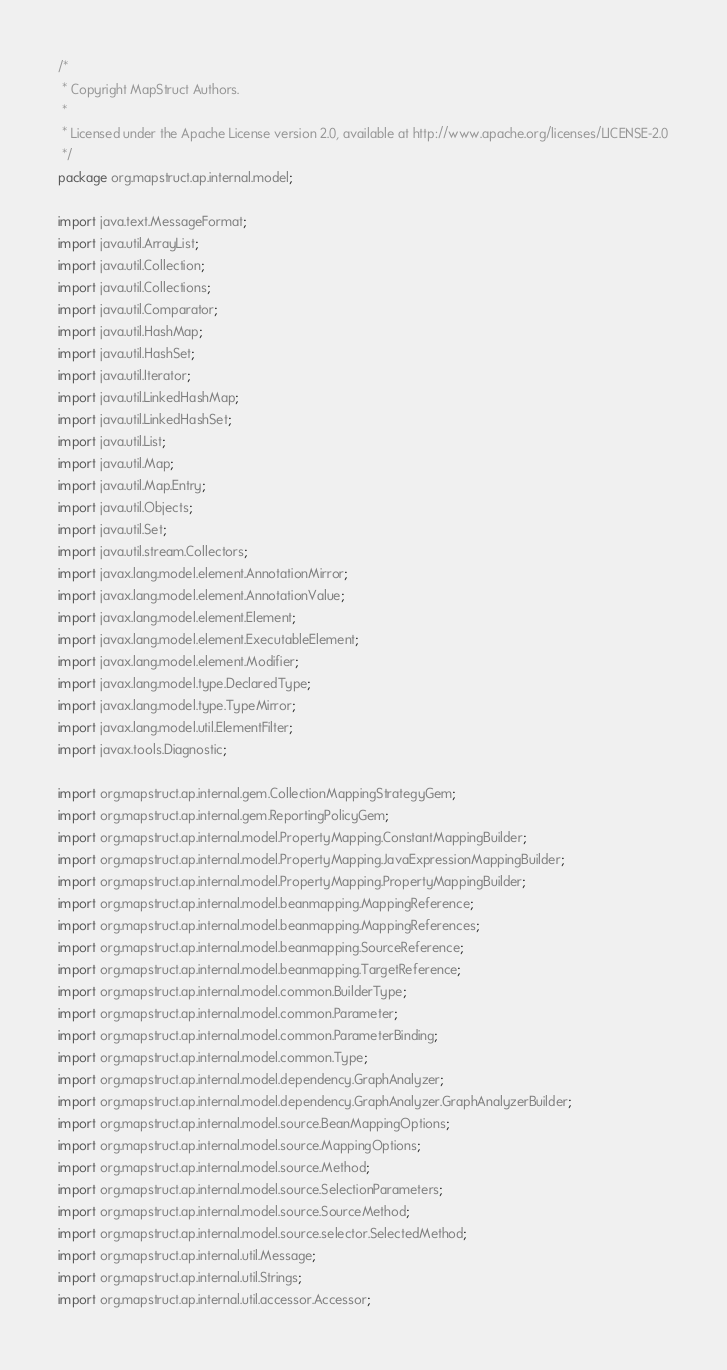<code> <loc_0><loc_0><loc_500><loc_500><_Java_>/*
 * Copyright MapStruct Authors.
 *
 * Licensed under the Apache License version 2.0, available at http://www.apache.org/licenses/LICENSE-2.0
 */
package org.mapstruct.ap.internal.model;

import java.text.MessageFormat;
import java.util.ArrayList;
import java.util.Collection;
import java.util.Collections;
import java.util.Comparator;
import java.util.HashMap;
import java.util.HashSet;
import java.util.Iterator;
import java.util.LinkedHashMap;
import java.util.LinkedHashSet;
import java.util.List;
import java.util.Map;
import java.util.Map.Entry;
import java.util.Objects;
import java.util.Set;
import java.util.stream.Collectors;
import javax.lang.model.element.AnnotationMirror;
import javax.lang.model.element.AnnotationValue;
import javax.lang.model.element.Element;
import javax.lang.model.element.ExecutableElement;
import javax.lang.model.element.Modifier;
import javax.lang.model.type.DeclaredType;
import javax.lang.model.type.TypeMirror;
import javax.lang.model.util.ElementFilter;
import javax.tools.Diagnostic;

import org.mapstruct.ap.internal.gem.CollectionMappingStrategyGem;
import org.mapstruct.ap.internal.gem.ReportingPolicyGem;
import org.mapstruct.ap.internal.model.PropertyMapping.ConstantMappingBuilder;
import org.mapstruct.ap.internal.model.PropertyMapping.JavaExpressionMappingBuilder;
import org.mapstruct.ap.internal.model.PropertyMapping.PropertyMappingBuilder;
import org.mapstruct.ap.internal.model.beanmapping.MappingReference;
import org.mapstruct.ap.internal.model.beanmapping.MappingReferences;
import org.mapstruct.ap.internal.model.beanmapping.SourceReference;
import org.mapstruct.ap.internal.model.beanmapping.TargetReference;
import org.mapstruct.ap.internal.model.common.BuilderType;
import org.mapstruct.ap.internal.model.common.Parameter;
import org.mapstruct.ap.internal.model.common.ParameterBinding;
import org.mapstruct.ap.internal.model.common.Type;
import org.mapstruct.ap.internal.model.dependency.GraphAnalyzer;
import org.mapstruct.ap.internal.model.dependency.GraphAnalyzer.GraphAnalyzerBuilder;
import org.mapstruct.ap.internal.model.source.BeanMappingOptions;
import org.mapstruct.ap.internal.model.source.MappingOptions;
import org.mapstruct.ap.internal.model.source.Method;
import org.mapstruct.ap.internal.model.source.SelectionParameters;
import org.mapstruct.ap.internal.model.source.SourceMethod;
import org.mapstruct.ap.internal.model.source.selector.SelectedMethod;
import org.mapstruct.ap.internal.util.Message;
import org.mapstruct.ap.internal.util.Strings;
import org.mapstruct.ap.internal.util.accessor.Accessor;</code> 